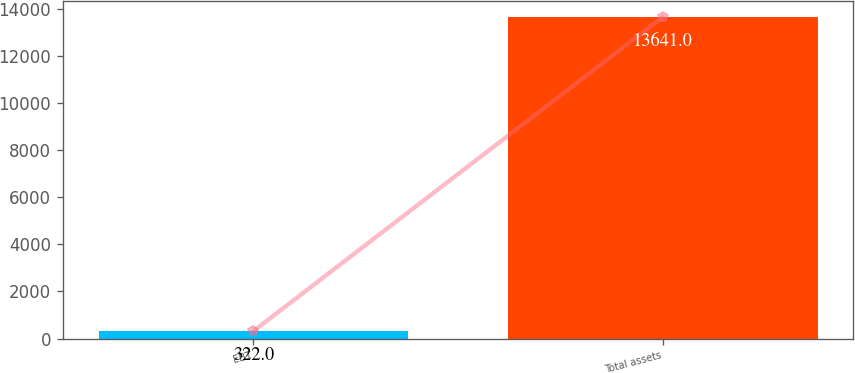Convert chart to OTSL. <chart><loc_0><loc_0><loc_500><loc_500><bar_chart><fcel>EBT<fcel>Total assets<nl><fcel>322<fcel>13641<nl></chart> 